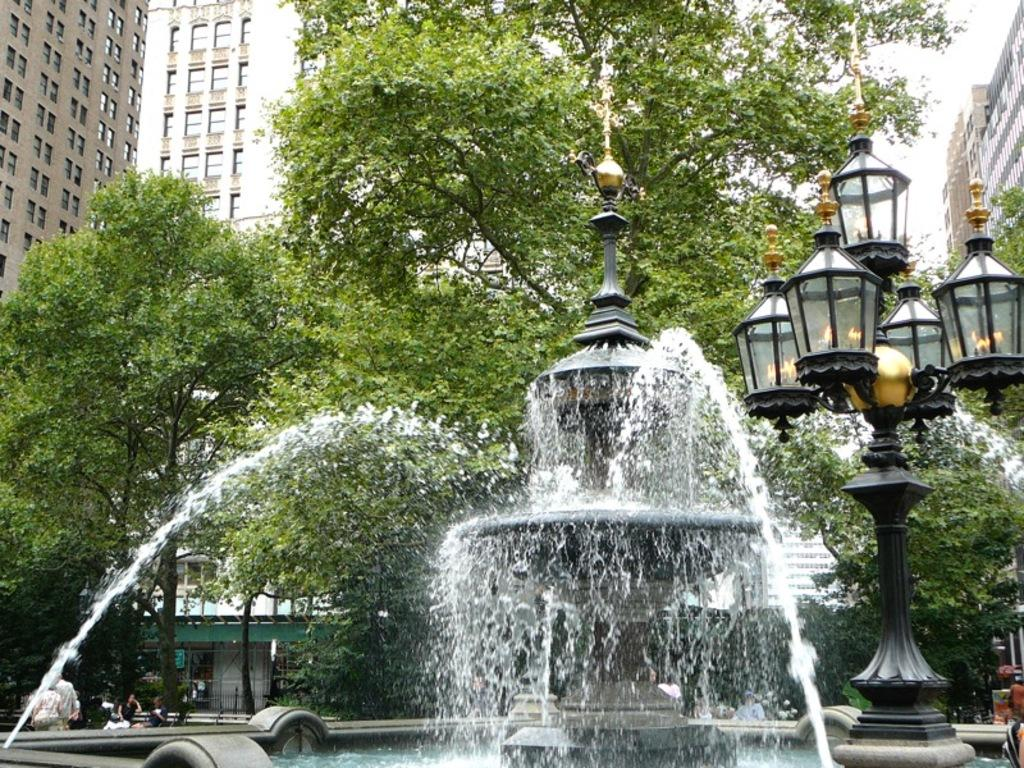What is the main feature in the image? There is a fountain in the image. What other structures can be seen in the image? There are street lamps on a pole, a fence, and buildings with windows in the image. Are there any natural elements present in the image? Yes, there is a group of trees in the image. What can be seen in the sky in the image? The sky is visible in the image. Are there any people in the image? Yes, there are people on the ground in the image. What type of lace can be seen on the fence in the image? There is no lace present on the fence in the image. How do the people in the image maintain their balance while walking? The image does not show people walking, so it is not possible to determine how they maintain their balance. 